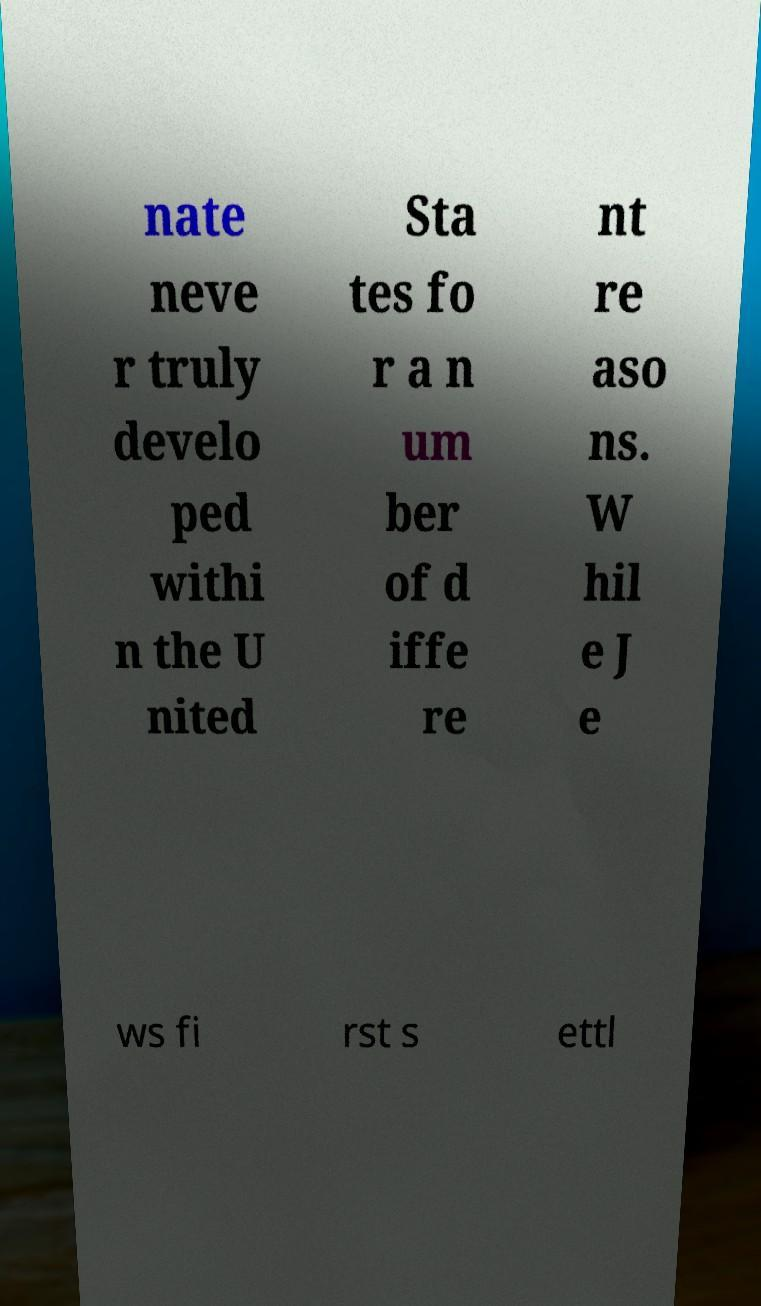Could you extract and type out the text from this image? nate neve r truly develo ped withi n the U nited Sta tes fo r a n um ber of d iffe re nt re aso ns. W hil e J e ws fi rst s ettl 